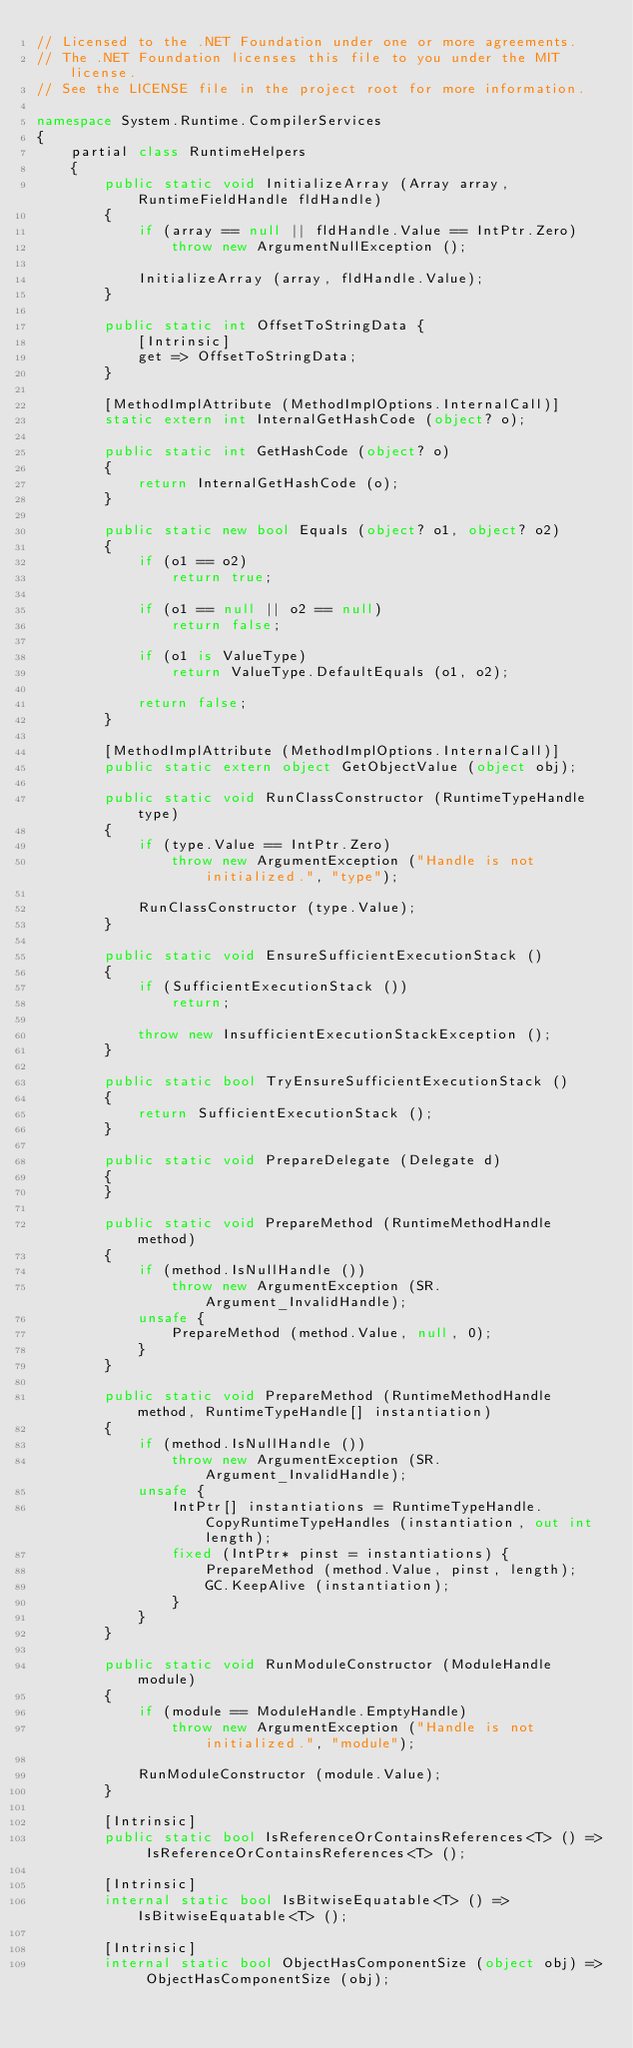Convert code to text. <code><loc_0><loc_0><loc_500><loc_500><_C#_>// Licensed to the .NET Foundation under one or more agreements.
// The .NET Foundation licenses this file to you under the MIT license.
// See the LICENSE file in the project root for more information.

namespace System.Runtime.CompilerServices
{
	partial class RuntimeHelpers
	{
		public static void InitializeArray (Array array, RuntimeFieldHandle fldHandle)
		{
			if (array == null || fldHandle.Value == IntPtr.Zero)
				throw new ArgumentNullException ();

			InitializeArray (array, fldHandle.Value);
		}

		public static int OffsetToStringData {
			[Intrinsic]
			get => OffsetToStringData;
		}

		[MethodImplAttribute (MethodImplOptions.InternalCall)]
		static extern int InternalGetHashCode (object? o);

		public static int GetHashCode (object? o)
		{
			return InternalGetHashCode (o);
		}

		public static new bool Equals (object? o1, object? o2)
		{
			if (o1 == o2)
				return true;

			if (o1 == null || o2 == null)
				return false;

			if (o1 is ValueType)
				return ValueType.DefaultEquals (o1, o2);

			return false;
		}

		[MethodImplAttribute (MethodImplOptions.InternalCall)]
		public static extern object GetObjectValue (object obj);

		public static void RunClassConstructor (RuntimeTypeHandle type)
		{
			if (type.Value == IntPtr.Zero)
				throw new ArgumentException ("Handle is not initialized.", "type");

			RunClassConstructor (type.Value);
		}

		public static void EnsureSufficientExecutionStack ()
		{
			if (SufficientExecutionStack ())
				return;

			throw new InsufficientExecutionStackException ();
		}

		public static bool TryEnsureSufficientExecutionStack ()
		{
			return SufficientExecutionStack ();
		}

		public static void PrepareDelegate (Delegate d)
		{
		}

		public static void PrepareMethod (RuntimeMethodHandle method)
		{
			if (method.IsNullHandle ())
				throw new ArgumentException (SR.Argument_InvalidHandle);
			unsafe {
				PrepareMethod (method.Value, null, 0);
			}
		}

		public static void PrepareMethod (RuntimeMethodHandle method, RuntimeTypeHandle[] instantiation)
		{
			if (method.IsNullHandle ())
				throw new ArgumentException (SR.Argument_InvalidHandle);
			unsafe {
				IntPtr[] instantiations = RuntimeTypeHandle.CopyRuntimeTypeHandles (instantiation, out int length);
				fixed (IntPtr* pinst = instantiations) {
					PrepareMethod (method.Value, pinst, length);
					GC.KeepAlive (instantiation);
				}
			}
		}

		public static void RunModuleConstructor (ModuleHandle module)
		{
			if (module == ModuleHandle.EmptyHandle)
				throw new ArgumentException ("Handle is not initialized.", "module");

			RunModuleConstructor (module.Value);
		}

		[Intrinsic]
		public static bool IsReferenceOrContainsReferences<T> () => IsReferenceOrContainsReferences<T> ();

		[Intrinsic]
		internal static bool IsBitwiseEquatable<T> () => IsBitwiseEquatable<T> ();

		[Intrinsic]
		internal static bool ObjectHasComponentSize (object obj) => ObjectHasComponentSize (obj);
</code> 